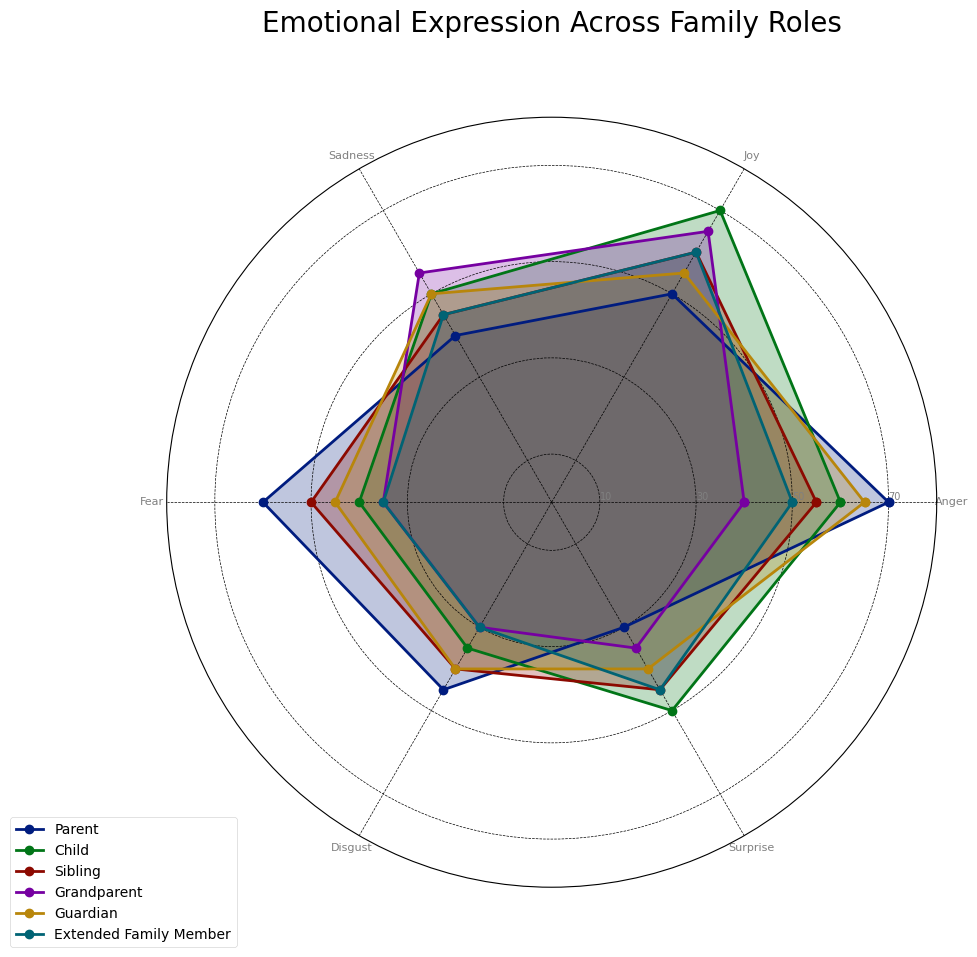What emotion has the highest expression for the 'Child' role? The 'Child' role's highest emotional expression can be identified by looking at the outermost point of each dimension for the 'Child' line (marked differently for each role). 'Joy' is the highest at point 70.
Answer: Joy Which family role has the lowest expression of 'Fear'? To find the lowest expression of 'Fear', look at the 'Fear' dimension and identify the family role with the lowest value. The 'Grandparent' role has the lowest expression at point 35.
Answer: Grandparent Is 'Sadness' expressed more by 'Parents' or 'Siblings'? Compare the positions of 'Parents' and 'Siblings' on the 'Sadness' dimension. The 'Parent' line is at 40, while the 'Sibling' line is at 45. Therefore, 'Siblings' express more sadness than 'Parents'.
Answer: Siblings What is the average expression level of 'Surprise' across all family roles? Calculate the average by summing up the 'Surprise' values for all roles and dividing by the number of roles. (30 + 50 + 45 + 35 + 40 + 45) / 6 = 40.83 (rounded to 40.8).
Answer: 40.8 Which role shows an equal level of 'Anger' and 'Joy'? Look for a role where the 'Anger' and 'Joy' dimensions have the same value. The 'Extended Family Member' role shows equal levels with both dimensions at 50 and 60, respectively (they aren't equal). Check again, no roles exhibit equal levels.
Answer: None Compare the expressions of 'Disgust' between 'Guardians' and 'Extended Family Members'. Who expresses more and by how much? Check the 'Disgust' dimension levels for each role. Guardians express 'Disgust' at 40, and Extended Family Members at 30. Therefore, Guardians express 'Disgust' more by 10 points.
Answer: Guardians by 10 What role has the most balanced emotional expression (the least variation in emotion levels)? Assess the variation in values for each role; the role with the smallest range (difference between the maximum and minimum values) is the most balanced. 'Grandparent' ranges from 30 to 65, a range of 35. Checking others, 'Extended Family Members' also shows a minimum range of 15 (30 to 45).
Answer: Extended Family Members What's the difference in 'Joy' expression between 'Guardians' and 'Grandparents'? Compare the 'Joy' values for both roles. Guardians express 'Joy' at 55 while Grandparents express it at 65. The difference is 65 - 55 = 10.
Answer: 10 Which role shows the maximum expression in 'Anger'? Check the 'Anger' dimension for the highest value. The 'Parent' role shows the maximum expression in 'Anger' at 70.
Answer: Parent 